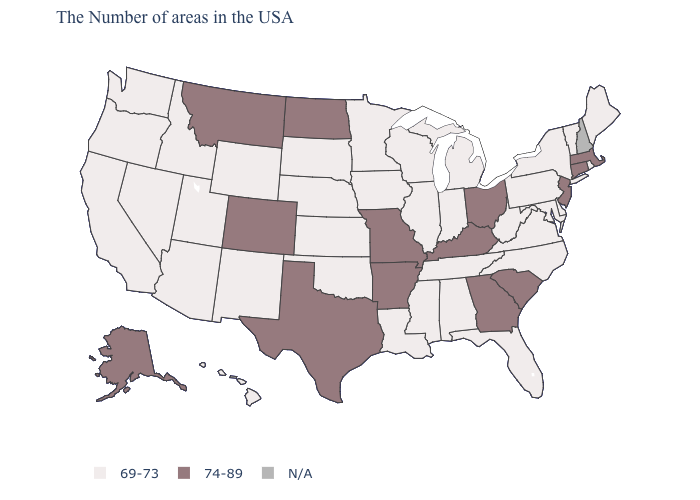What is the value of West Virginia?
Keep it brief. 69-73. Which states have the highest value in the USA?
Write a very short answer. Massachusetts, Connecticut, New Jersey, South Carolina, Ohio, Georgia, Kentucky, Missouri, Arkansas, Texas, North Dakota, Colorado, Montana, Alaska. What is the value of Nevada?
Give a very brief answer. 69-73. What is the value of New Mexico?
Keep it brief. 69-73. What is the value of Nebraska?
Give a very brief answer. 69-73. Name the states that have a value in the range 69-73?
Quick response, please. Maine, Rhode Island, Vermont, New York, Delaware, Maryland, Pennsylvania, Virginia, North Carolina, West Virginia, Florida, Michigan, Indiana, Alabama, Tennessee, Wisconsin, Illinois, Mississippi, Louisiana, Minnesota, Iowa, Kansas, Nebraska, Oklahoma, South Dakota, Wyoming, New Mexico, Utah, Arizona, Idaho, Nevada, California, Washington, Oregon, Hawaii. Does Alaska have the highest value in the USA?
Answer briefly. Yes. Does New Jersey have the highest value in the Northeast?
Write a very short answer. Yes. Which states have the lowest value in the Northeast?
Write a very short answer. Maine, Rhode Island, Vermont, New York, Pennsylvania. What is the lowest value in the South?
Write a very short answer. 69-73. Does South Carolina have the lowest value in the USA?
Write a very short answer. No. How many symbols are there in the legend?
Write a very short answer. 3. Name the states that have a value in the range 69-73?
Answer briefly. Maine, Rhode Island, Vermont, New York, Delaware, Maryland, Pennsylvania, Virginia, North Carolina, West Virginia, Florida, Michigan, Indiana, Alabama, Tennessee, Wisconsin, Illinois, Mississippi, Louisiana, Minnesota, Iowa, Kansas, Nebraska, Oklahoma, South Dakota, Wyoming, New Mexico, Utah, Arizona, Idaho, Nevada, California, Washington, Oregon, Hawaii. What is the lowest value in states that border Missouri?
Give a very brief answer. 69-73. Name the states that have a value in the range 69-73?
Write a very short answer. Maine, Rhode Island, Vermont, New York, Delaware, Maryland, Pennsylvania, Virginia, North Carolina, West Virginia, Florida, Michigan, Indiana, Alabama, Tennessee, Wisconsin, Illinois, Mississippi, Louisiana, Minnesota, Iowa, Kansas, Nebraska, Oklahoma, South Dakota, Wyoming, New Mexico, Utah, Arizona, Idaho, Nevada, California, Washington, Oregon, Hawaii. 